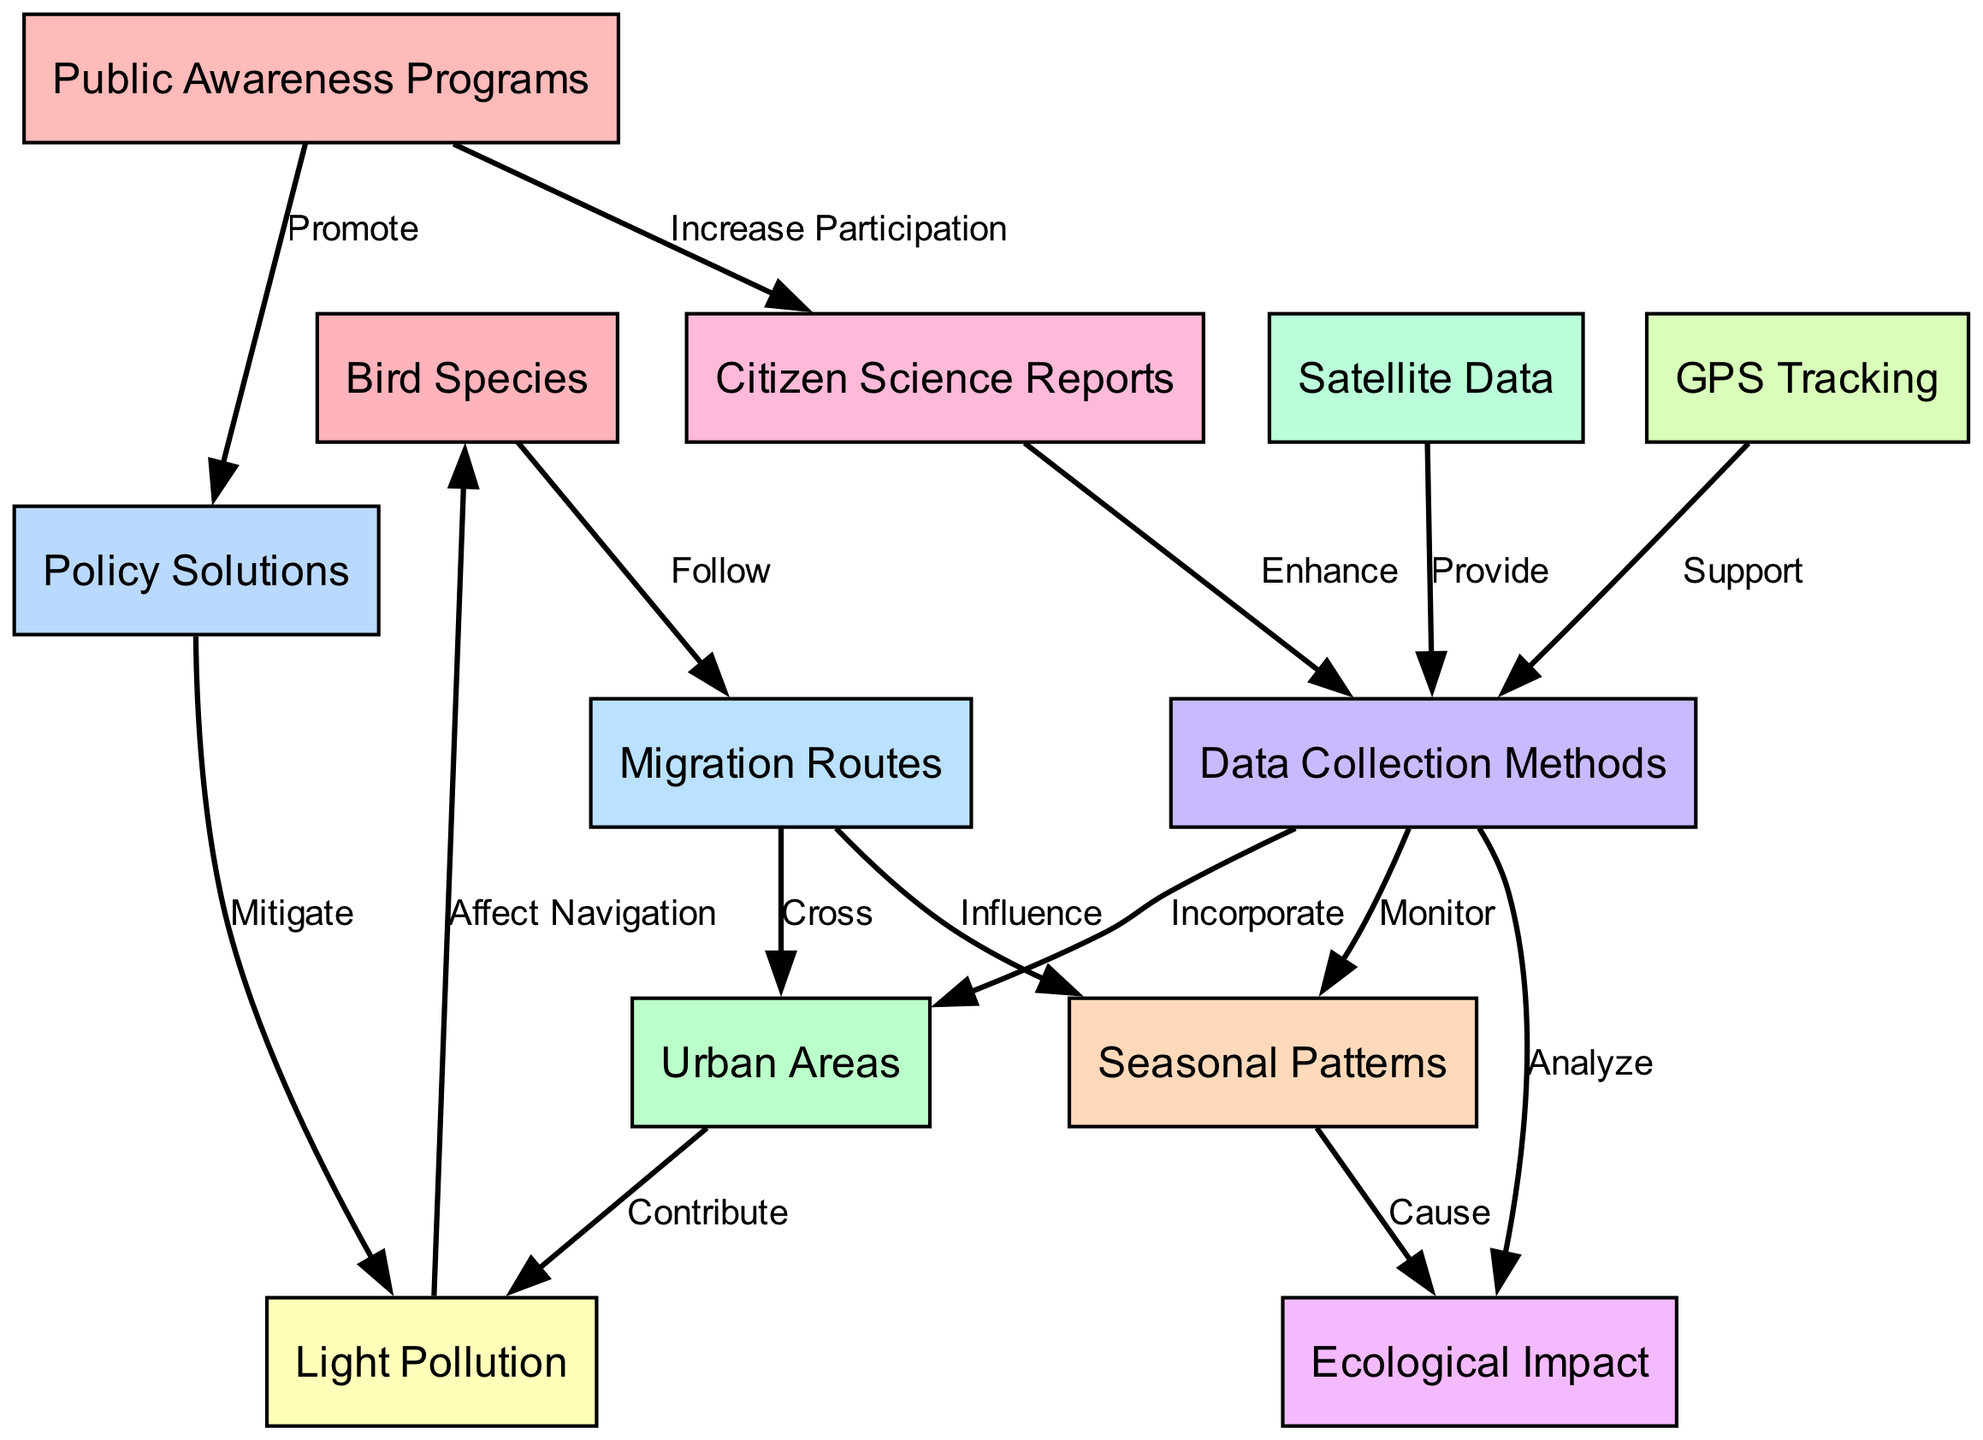What is the total number of nodes in the diagram? The nodes listed in the diagram include bird species, urban areas, migration routes, light pollution, seasonal patterns, ecological impact, data collection methods, satellite data, GPS tracking, citizen science reports, policy solutions, and public awareness programs. Counting these gives a total of 12 nodes.
Answer: 12 Which node directly affects bird species? In the diagram, light pollution has a direct edge labeled "Affect Navigation" to bird species, indicating its influence on their behavior.
Answer: Light Pollution How many edges connect migration routes to urban areas? The diagram shows a single edge labeled "Cross" connecting migration routes to urban areas, indicating a direct relationship between them.
Answer: 1 What is the role of citizen science in data collection? The diagram signifies that citizen science enhances the data collection methods, establishing its supportive role in gathering information about bird migration.
Answer: Enhance What is the relationship between seasonal patterns and ecological impact? The diagram illustrates that seasonal patterns cause ecological impact, showing that changes in migration due to seasons can have broader ecological effects.
Answer: Cause How does public awareness relate to policy solutions? The diagram indicates that public awareness promotes policy solutions, suggesting that raising awareness can lead to the implementation of strategies to mitigate light pollution.
Answer: Promote What method of data collection supports seasonal patterns? The flow of the diagram indicates that data collection methods monitor seasonal patterns, which highlights how tracking data can help understand migration changes over seasons.
Answer: Monitor In what way does light pollution contribute to urban areas? The edge connecting urban areas to light pollution indicates that urban areas contribute to light pollution, suggesting a direct influence of city infrastructures on the surrounding environment.
Answer: Contribute Which data collection method utilizes satellite data? According to the diagram, data collection methods receive support from satellite data, showing the interconnectedness of these two elements in monitoring migration patterns.
Answer: Provide 